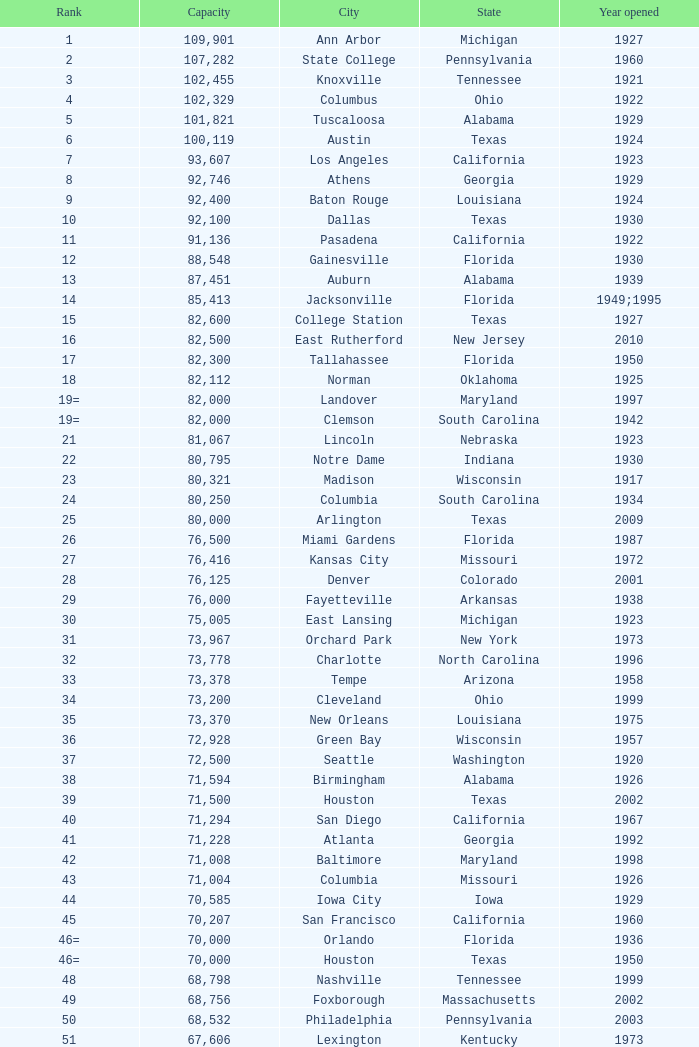What is the city in Alabama that opened in 1996? Huntsville. 